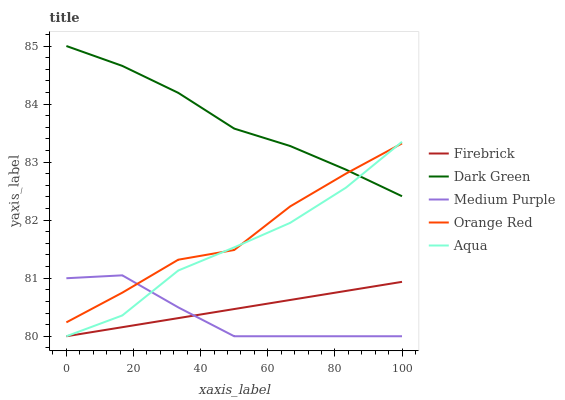Does Firebrick have the minimum area under the curve?
Answer yes or no. No. Does Firebrick have the maximum area under the curve?
Answer yes or no. No. Is Aqua the smoothest?
Answer yes or no. No. Is Aqua the roughest?
Answer yes or no. No. Does Orange Red have the lowest value?
Answer yes or no. No. Does Aqua have the highest value?
Answer yes or no. No. Is Firebrick less than Dark Green?
Answer yes or no. Yes. Is Dark Green greater than Medium Purple?
Answer yes or no. Yes. Does Firebrick intersect Dark Green?
Answer yes or no. No. 